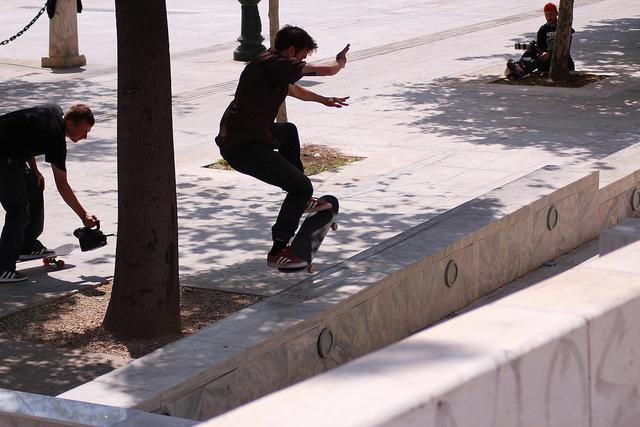What past time is the rightmost person involved in? skateboarding 